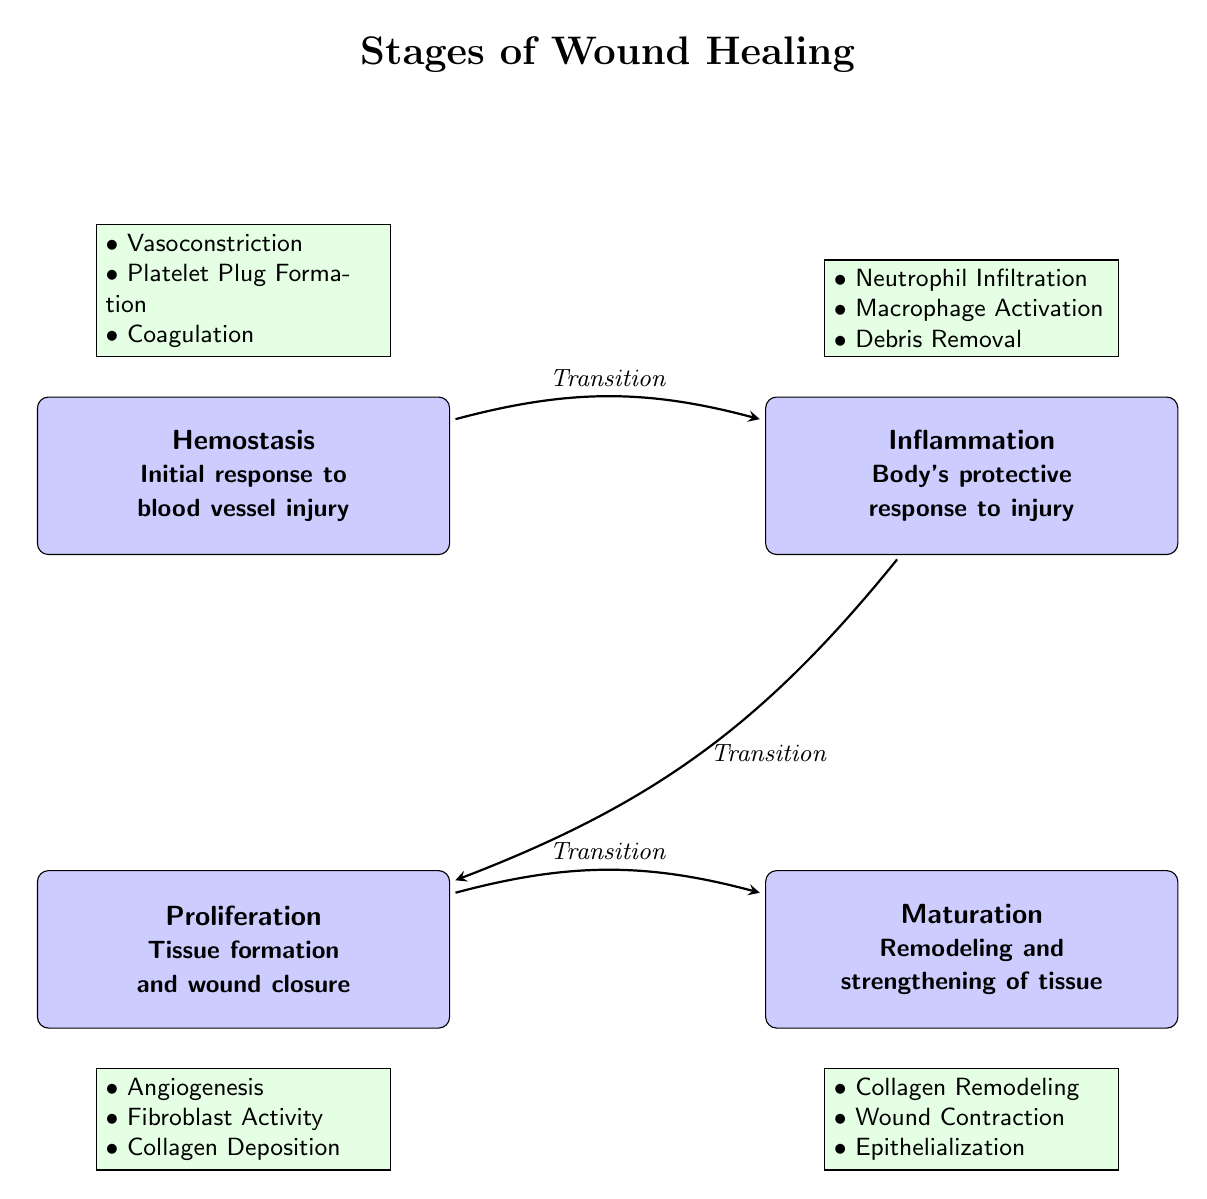What are the four phases of wound healing depicted in the diagram? The diagram lists four phases of wound healing starting from hemostasis, then inflammation, followed by proliferation, and finally maturation. Therefore, the four phases are Hemostasis, Inflammation, Proliferation, Maturation.
Answer: Hemostasis, Inflammation, Proliferation, Maturation What is the first process that occurs during hemostasis? In the diagram, the first process listed under hemostasis is vasoconstriction, which is the initial response of blood vessels to injury.
Answer: Vasoconstriction How many processes are detailed under the inflammation phase? The diagram details three processes under the inflammation phase: Neutrophil Infiltration, Macrophage Activation, and Debris Removal. Thus, the total number of processes is three.
Answer: 3 What transition occurs after inflammation? The diagram indicates a transition from inflammation to proliferation. This is depicted with an arrow labeled "Transition" connecting the two phases, indicating that proliferation follows inflammation.
Answer: Transition Which phase includes collagen deposition as a process? The diagram shows collagen deposition as one of the processes listed under the proliferation phase. By identifying the processes, we find that collagen deposition is specifically associated with the proliferation phase.
Answer: Proliferation What is the main purpose of the maturation phase? The diagram indicates that the main purpose of the maturation phase is remodeling and strengthening of tissue, which is conveyed through the text within the phase box.
Answer: Remodeling and strengthening of tissue Which processes occur during maturation according to the diagram? According to the diagram, the processes occurring during maturation include Collagen Remodeling, Wound Contraction, and Epithelialization. By listing these processes, we can summarize the activities involved in this phase.
Answer: Collagen Remodeling, Wound Contraction, Epithelialization What is the relationship between hemostasis and inflammation? The relationship is defined as a transition where inflammation directly follows hemostasis. The diagram illustrates this with an arrow labeled "Transition" going from hemostasis to inflammation.
Answer: Transition Which phase has processes related to tissue formation? The proliferation phase contains the processes that are specifically related to tissue formation, such as Angiogenesis and Fibroblast Activity, as outlined in the diagram.
Answer: Proliferation 